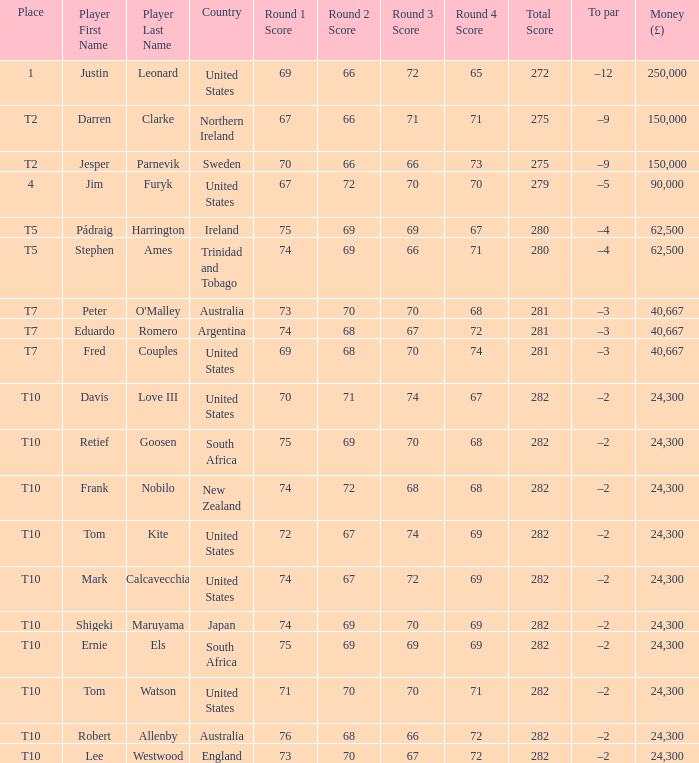How much money has been won by Stephen Ames? 62500.0. 